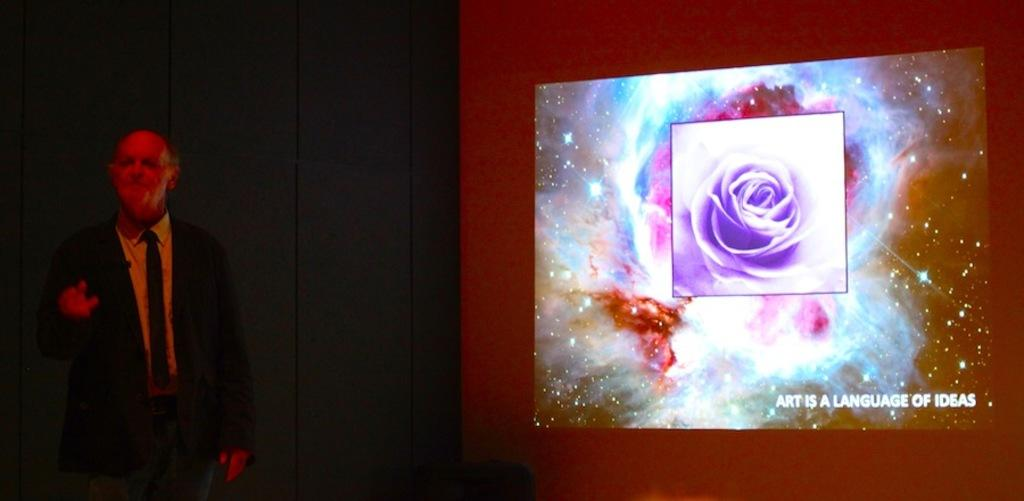Who is present in the image? There is a man in the image. What is the man doing in the image? The man is standing in the image. What is the man wearing in the image? The man is wearing a suit in the image. What can be seen on the right side of the image? There is a screen on the right side of the image. What is displayed on the screen? There is a flower visible on the screen, and there is also text visible on the screen. What type of cakes is the man holding in the image? There are no cakes present in the image; the man is not holding anything. Can you see a pipe in the image? There is no pipe present in the image. 